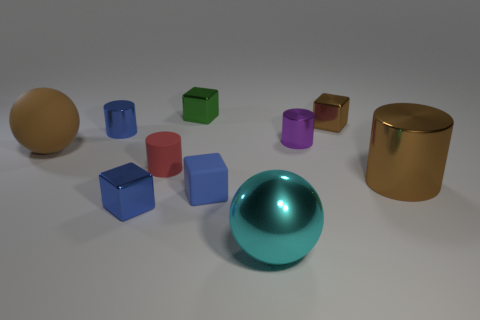Is the color of the rubber ball the same as the big cylinder?
Give a very brief answer. Yes. There is a tiny blue shiny object on the right side of the tiny blue shiny object behind the tiny purple object; what shape is it?
Your answer should be very brief. Cube. Is there a yellow cylinder of the same size as the brown metallic cube?
Give a very brief answer. No. Are there fewer tiny red rubber cylinders than tiny yellow metallic cubes?
Your answer should be compact. No. What shape is the blue metallic object that is behind the tiny metallic cylinder right of the small metallic thing in front of the red thing?
Ensure brevity in your answer.  Cylinder. How many objects are either cylinders that are right of the small brown shiny block or big shiny things to the right of the brown cube?
Give a very brief answer. 1. Are there any big brown objects in front of the large brown rubber sphere?
Your response must be concise. Yes. What number of things are either green things that are left of the small brown thing or blue matte objects?
Your answer should be very brief. 2. What number of blue objects are either cubes or tiny metal things?
Give a very brief answer. 3. How many other objects are the same color as the large shiny ball?
Your answer should be compact. 0. 